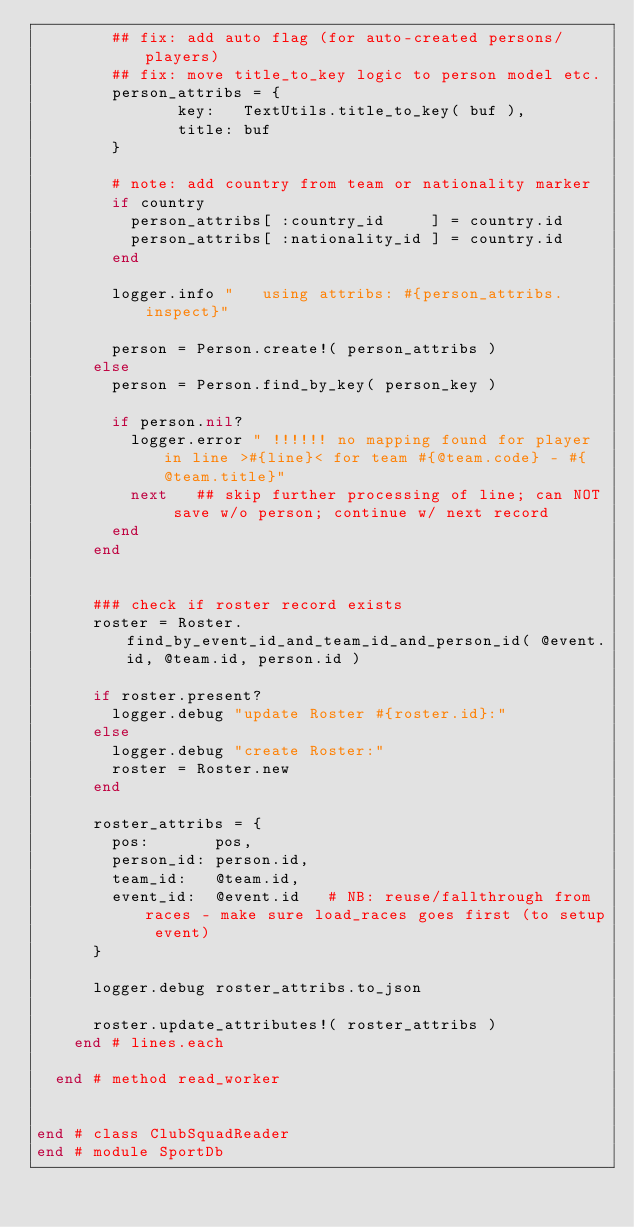Convert code to text. <code><loc_0><loc_0><loc_500><loc_500><_Ruby_>        ## fix: add auto flag (for auto-created persons/players)
        ## fix: move title_to_key logic to person model etc.
        person_attribs = {
               key:   TextUtils.title_to_key( buf ),
               title: buf
        }

        # note: add country from team or nationality marker
        if country
          person_attribs[ :country_id     ] = country.id
          person_attribs[ :nationality_id ] = country.id
        end

        logger.info "   using attribs: #{person_attribs.inspect}"

        person = Person.create!( person_attribs )
      else
        person = Person.find_by_key( person_key )

        if person.nil?
          logger.error " !!!!!! no mapping found for player in line >#{line}< for team #{@team.code} - #{@team.title}"
          next   ## skip further processing of line; can NOT save w/o person; continue w/ next record
        end
      end


      ### check if roster record exists
      roster = Roster.find_by_event_id_and_team_id_and_person_id( @event.id, @team.id, person.id )

      if roster.present?
        logger.debug "update Roster #{roster.id}:"
      else
        logger.debug "create Roster:"
        roster = Roster.new
      end

      roster_attribs = {
        pos:       pos,
        person_id: person.id,
        team_id:   @team.id,
        event_id:  @event.id   # NB: reuse/fallthrough from races - make sure load_races goes first (to setup event)
      }

      logger.debug roster_attribs.to_json

      roster.update_attributes!( roster_attribs )
    end # lines.each

  end # method read_worker


end # class ClubSquadReader
end # module SportDb
</code> 